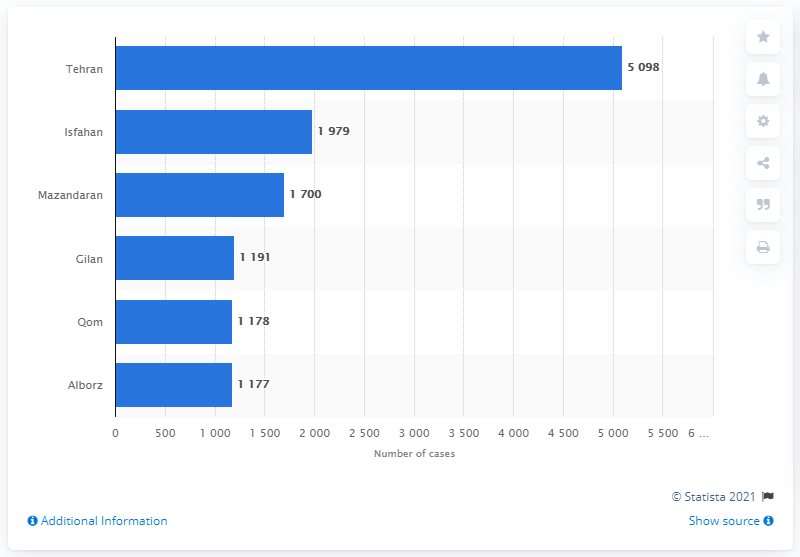Draw attention to some important aspects in this diagram. The province of Tehran was the most severely impacted by the coronavirus pandemic. The first confirmed case of coronavirus in Iran was reported in the city of Qom. 